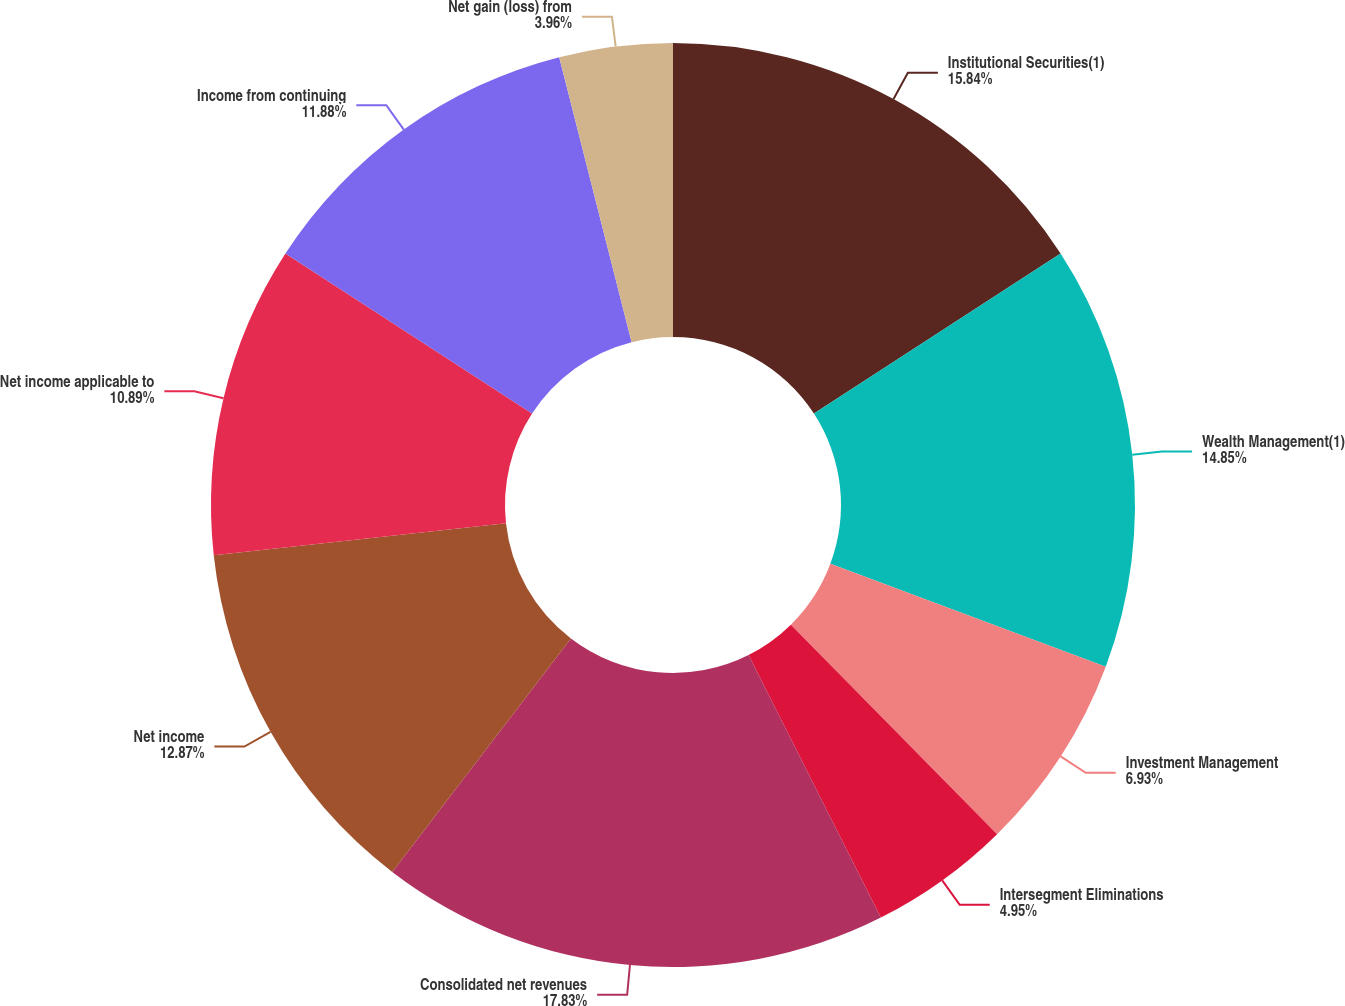<chart> <loc_0><loc_0><loc_500><loc_500><pie_chart><fcel>Institutional Securities(1)<fcel>Wealth Management(1)<fcel>Investment Management<fcel>Intersegment Eliminations<fcel>Consolidated net revenues<fcel>Net income<fcel>Net income applicable to<fcel>Income from continuing<fcel>Net gain (loss) from<nl><fcel>15.84%<fcel>14.85%<fcel>6.93%<fcel>4.95%<fcel>17.82%<fcel>12.87%<fcel>10.89%<fcel>11.88%<fcel>3.96%<nl></chart> 